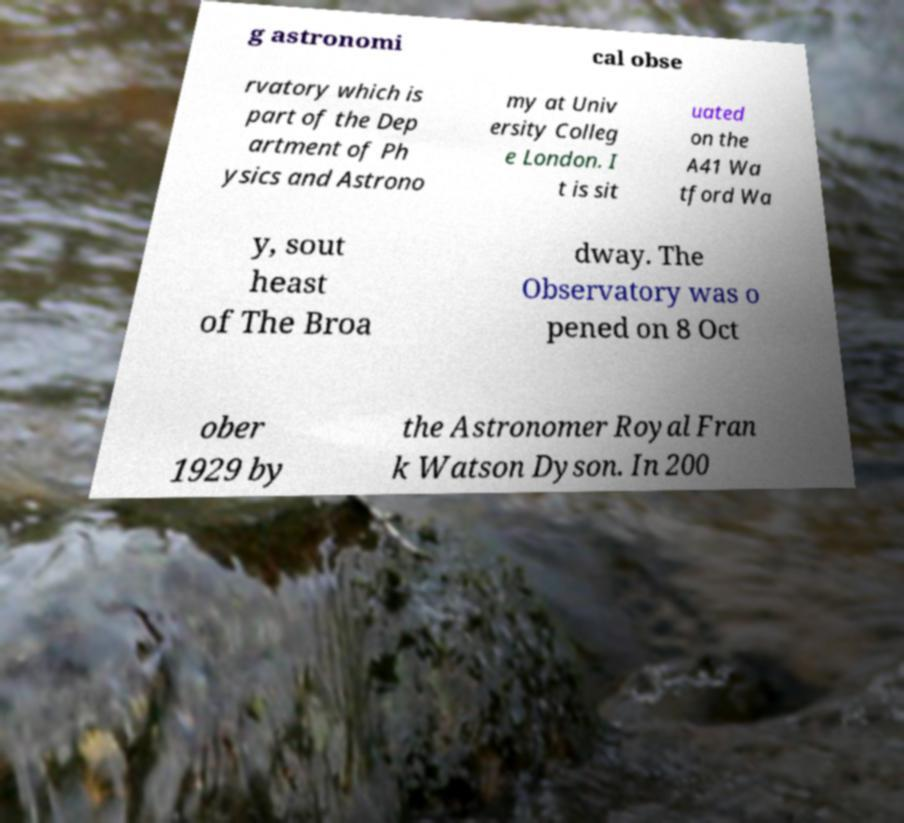Could you extract and type out the text from this image? g astronomi cal obse rvatory which is part of the Dep artment of Ph ysics and Astrono my at Univ ersity Colleg e London. I t is sit uated on the A41 Wa tford Wa y, sout heast of The Broa dway. The Observatory was o pened on 8 Oct ober 1929 by the Astronomer Royal Fran k Watson Dyson. In 200 